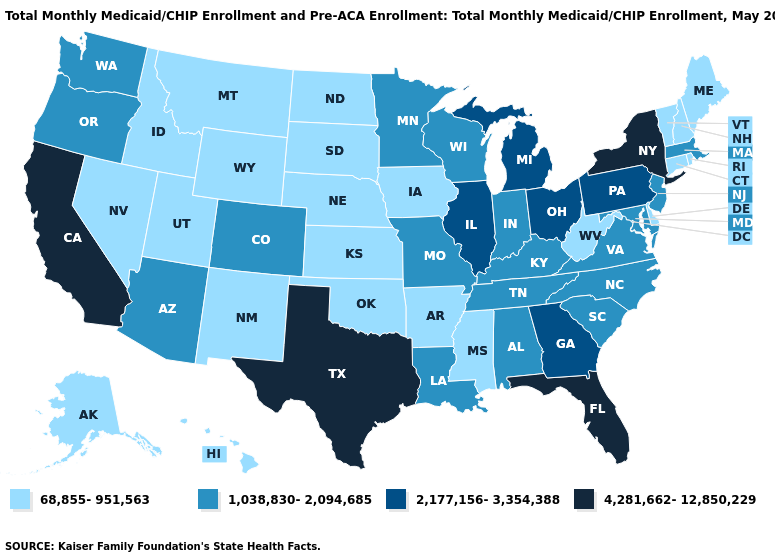What is the highest value in the USA?
Be succinct. 4,281,662-12,850,229. Name the states that have a value in the range 68,855-951,563?
Write a very short answer. Alaska, Arkansas, Connecticut, Delaware, Hawaii, Idaho, Iowa, Kansas, Maine, Mississippi, Montana, Nebraska, Nevada, New Hampshire, New Mexico, North Dakota, Oklahoma, Rhode Island, South Dakota, Utah, Vermont, West Virginia, Wyoming. Which states have the lowest value in the MidWest?
Write a very short answer. Iowa, Kansas, Nebraska, North Dakota, South Dakota. What is the value of Florida?
Concise answer only. 4,281,662-12,850,229. Does the first symbol in the legend represent the smallest category?
Concise answer only. Yes. Does Oregon have a higher value than Washington?
Give a very brief answer. No. What is the value of Florida?
Concise answer only. 4,281,662-12,850,229. What is the lowest value in the Northeast?
Quick response, please. 68,855-951,563. Among the states that border New Hampshire , does Massachusetts have the highest value?
Concise answer only. Yes. Which states hav the highest value in the South?
Be succinct. Florida, Texas. What is the value of Montana?
Give a very brief answer. 68,855-951,563. What is the value of Wyoming?
Quick response, please. 68,855-951,563. Which states have the highest value in the USA?
Give a very brief answer. California, Florida, New York, Texas. Does Montana have the highest value in the West?
Short answer required. No. Does New Jersey have the same value as Nebraska?
Give a very brief answer. No. 